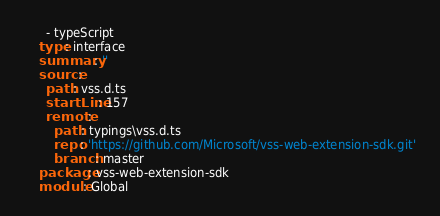<code> <loc_0><loc_0><loc_500><loc_500><_YAML_>      - typeScript
    type: interface
    summary: ''
    source:
      path: vss.d.ts
      startLine: 157
      remote:
        path: typings\vss.d.ts
        repo: 'https://github.com/Microsoft/vss-web-extension-sdk.git'
        branch: master
    package: vss-web-extension-sdk
    module: Global
</code> 